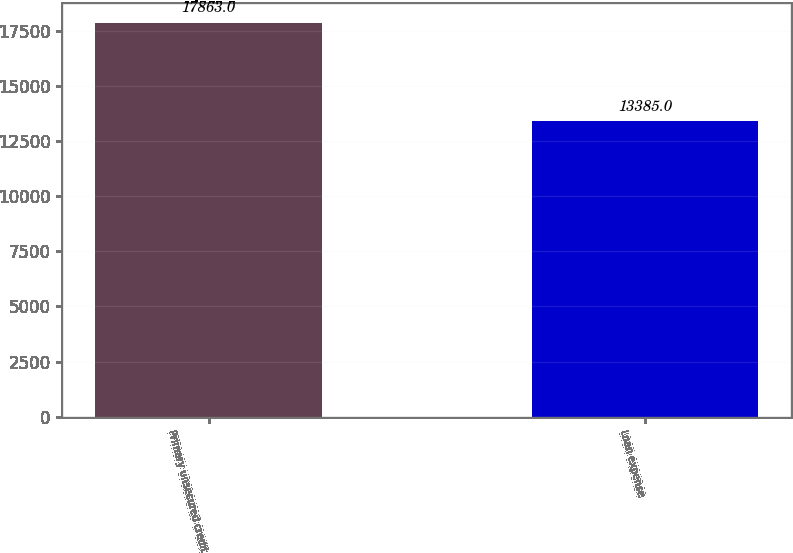Convert chart to OTSL. <chart><loc_0><loc_0><loc_500><loc_500><bar_chart><fcel>Primary unsecured credit<fcel>Loan expense<nl><fcel>17863<fcel>13385<nl></chart> 